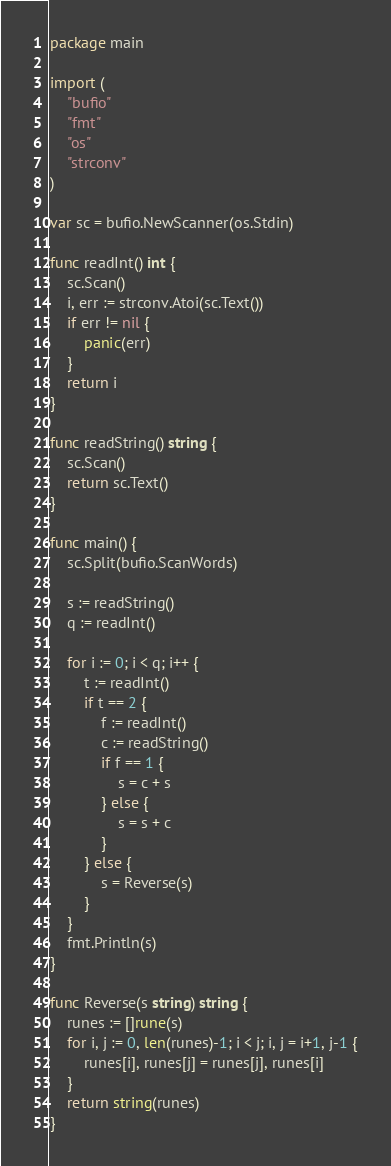<code> <loc_0><loc_0><loc_500><loc_500><_Go_>package main

import (
	"bufio"
	"fmt"
	"os"
	"strconv"
)

var sc = bufio.NewScanner(os.Stdin)

func readInt() int {
	sc.Scan()
	i, err := strconv.Atoi(sc.Text())
	if err != nil {
		panic(err)
	}
	return i
}

func readString() string {
	sc.Scan()
	return sc.Text()
}

func main() {
	sc.Split(bufio.ScanWords)

	s := readString()
	q := readInt()

	for i := 0; i < q; i++ {
		t := readInt()
		if t == 2 {
			f := readInt()
			c := readString()
			if f == 1 {
				s = c + s
			} else {
				s = s + c
			}
		} else {
			s = Reverse(s)
		}
	}
	fmt.Println(s)
}

func Reverse(s string) string {
	runes := []rune(s)
	for i, j := 0, len(runes)-1; i < j; i, j = i+1, j-1 {
		runes[i], runes[j] = runes[j], runes[i]
	}
	return string(runes)
}
</code> 